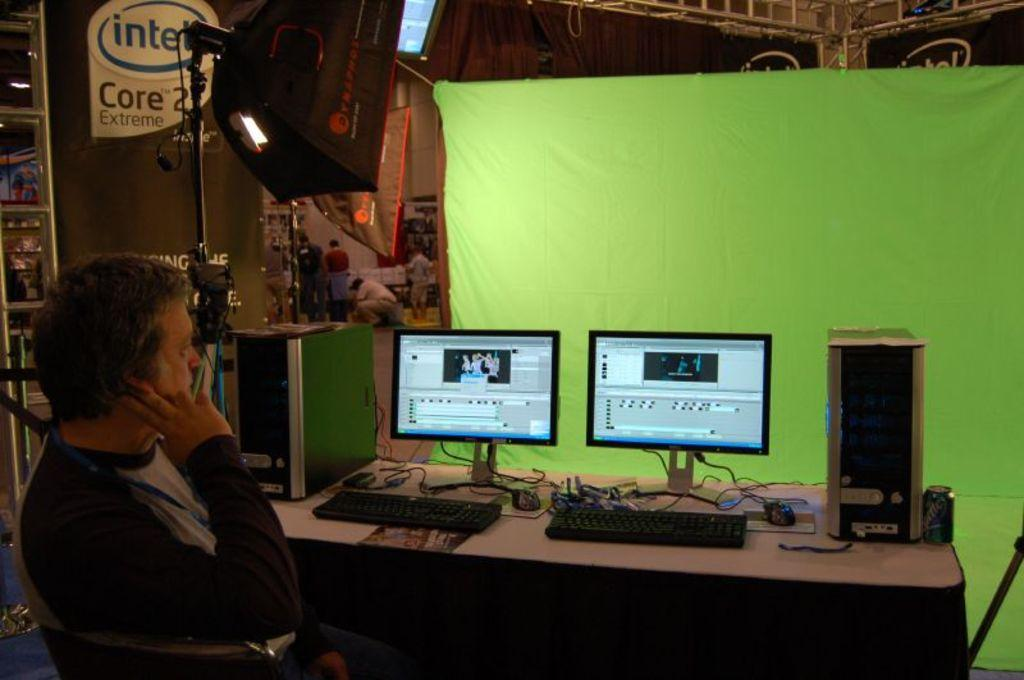Provide a one-sentence caption for the provided image. A man sits near an Intel Core 2 Extreme ad while looking at two computer monitors. 